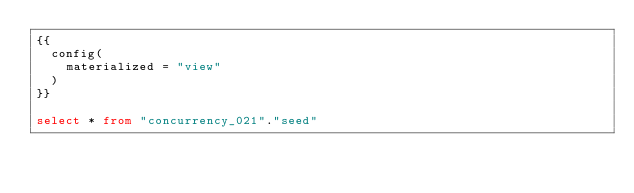Convert code to text. <code><loc_0><loc_0><loc_500><loc_500><_SQL_>{{
  config(
    materialized = "view"
  )
}}

select * from "concurrency_021"."seed"
</code> 